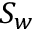<formula> <loc_0><loc_0><loc_500><loc_500>S _ { w }</formula> 